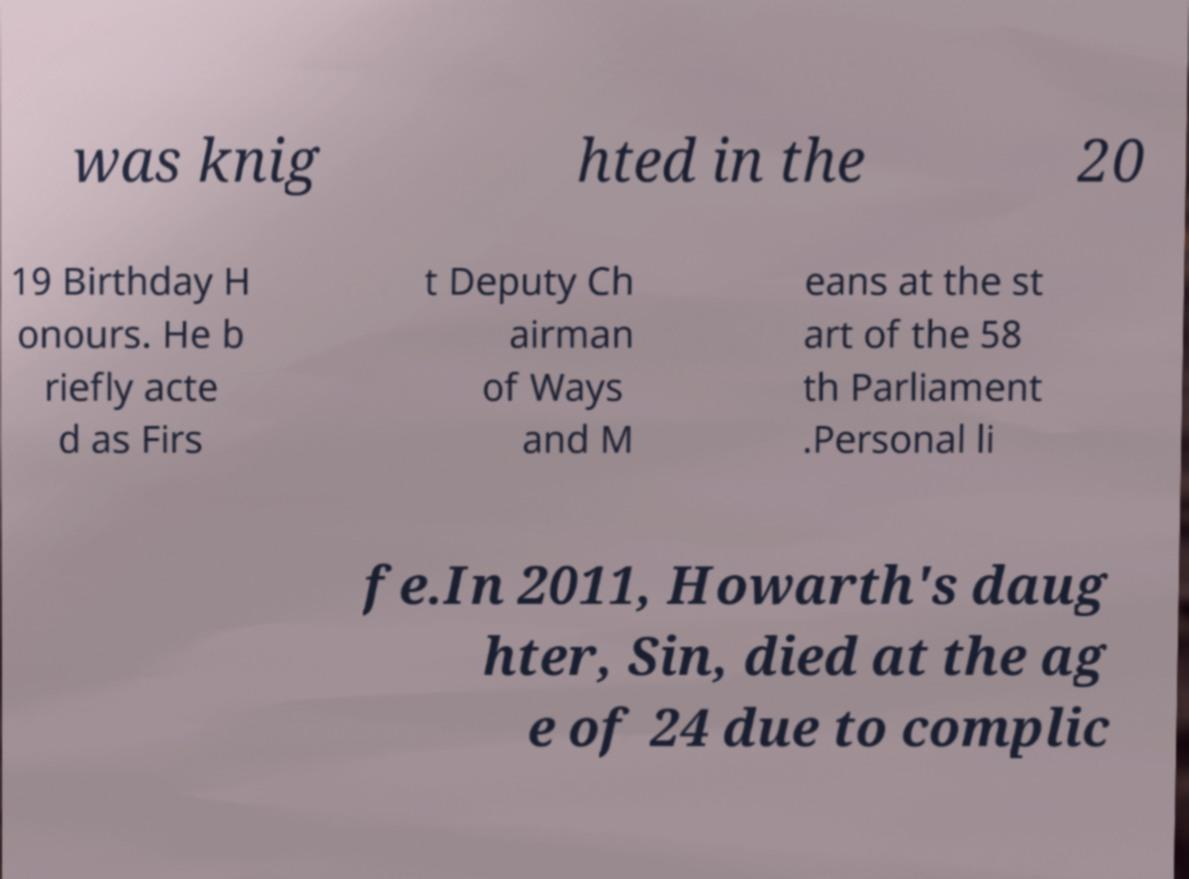I need the written content from this picture converted into text. Can you do that? was knig hted in the 20 19 Birthday H onours. He b riefly acte d as Firs t Deputy Ch airman of Ways and M eans at the st art of the 58 th Parliament .Personal li fe.In 2011, Howarth's daug hter, Sin, died at the ag e of 24 due to complic 